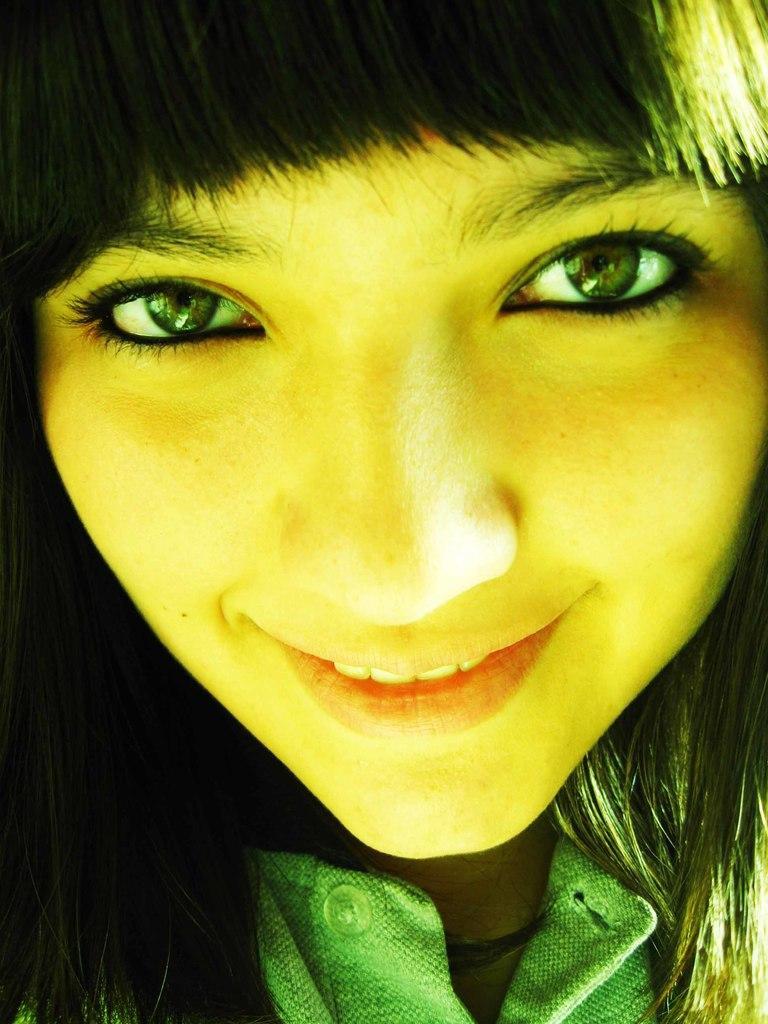Please provide a concise description of this image. There is a lady wearing a green dress is smiling. 